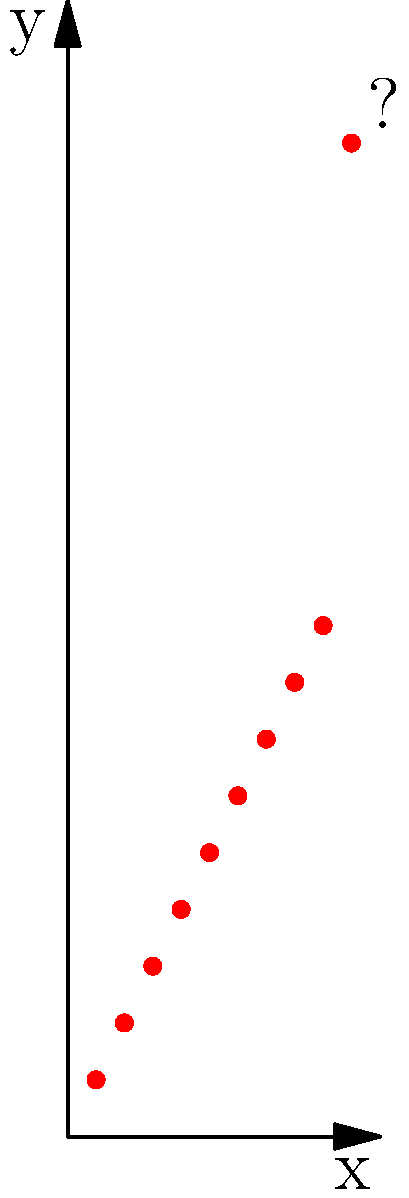In the scatter plot of research data shown above, which statistical method would be most appropriate for identifying the potential outlier, and what threshold would you recommend for classifying a point as an outlier? To identify outliers in a scatter plot of research data, we can follow these steps:

1. Observe the data: The scatter plot shows a clear linear trend with one point (10, 35) that appears to deviate significantly from this trend.

2. Choose an appropriate method: For this dataset, the z-score method or the Interquartile Range (IQR) method would be suitable. Let's use the z-score method as it's commonly used in research settings.

3. Calculate z-scores:
   a. Compute the mean ($\mu$) and standard deviation ($\sigma$) of the y-values.
   b. For each point, calculate its z-score using the formula: $z = \frac{y - \mu}{\sigma}$

4. Set a threshold: Typically, points with |z-score| > 3 are considered potential outliers in normally distributed data.

5. Apply the method:
   $\mu \approx 12.5$
   $\sigma \approx 9.79$
   
   For the point (10, 35):
   $z = \frac{35 - 12.5}{9.79} \approx 2.30$

6. Interpret the result: While this point has the highest z-score, it doesn't exceed the typical threshold of 3. However, given the clear visual deviation and the relatively small sample size, it could still be considered a potential outlier.

7. Recommend a threshold: Given the small sample size and clear visual deviation, a more conservative threshold of |z-score| > 2 could be appropriate for this dataset.
Answer: Z-score method with a threshold of |z| > 2 